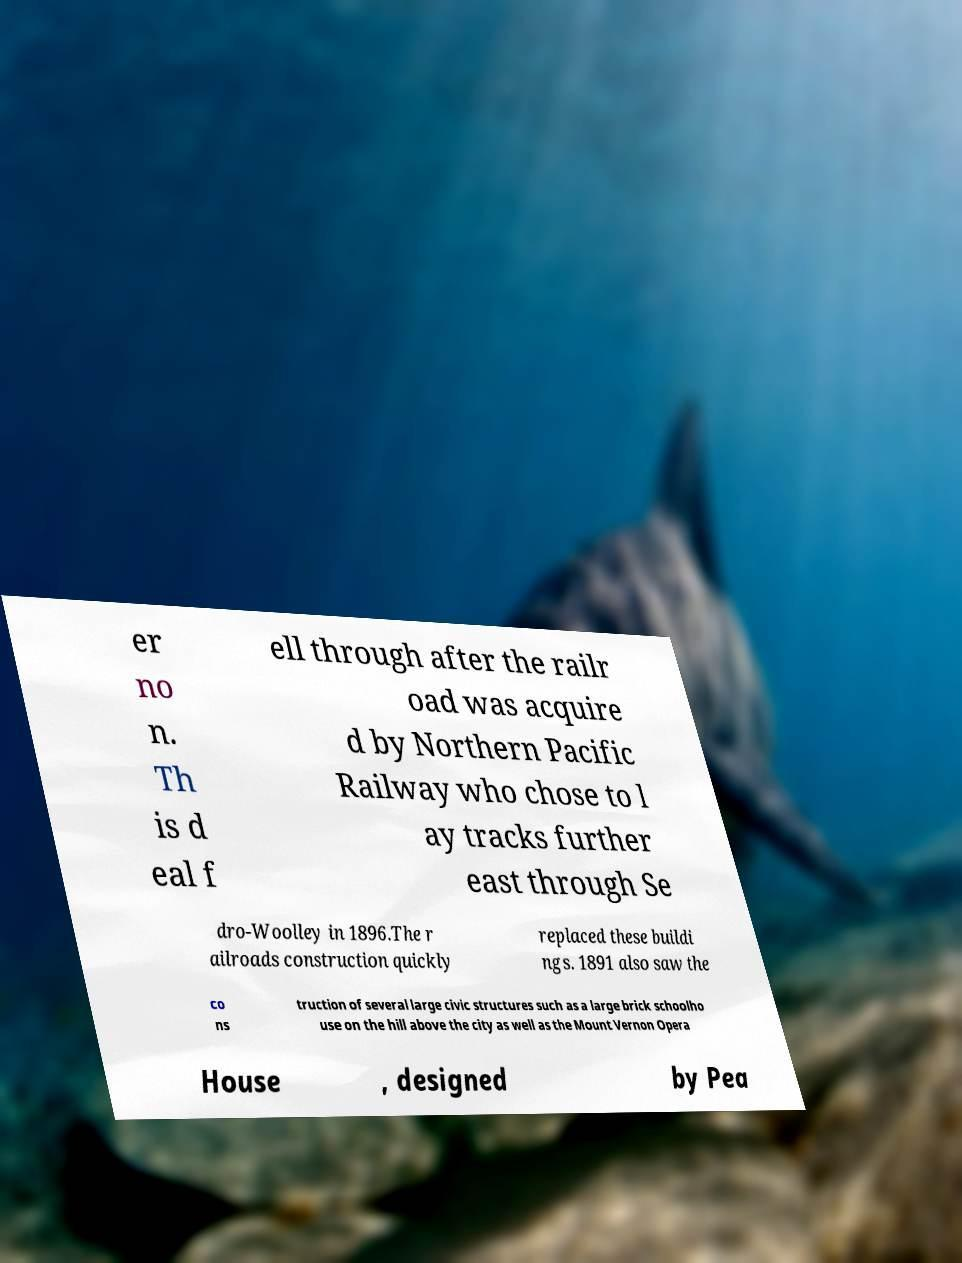What messages or text are displayed in this image? I need them in a readable, typed format. er no n. Th is d eal f ell through after the railr oad was acquire d by Northern Pacific Railway who chose to l ay tracks further east through Se dro-Woolley in 1896.The r ailroads construction quickly replaced these buildi ngs. 1891 also saw the co ns truction of several large civic structures such as a large brick schoolho use on the hill above the city as well as the Mount Vernon Opera House , designed by Pea 